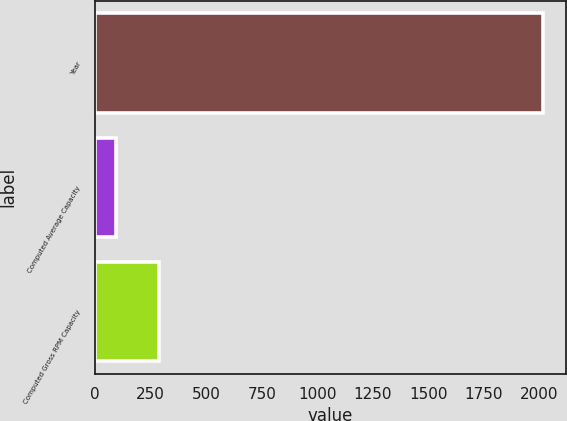Convert chart. <chart><loc_0><loc_0><loc_500><loc_500><bar_chart><fcel>Year<fcel>Computed Average Capacity<fcel>Computed Gross RPM Capacity<nl><fcel>2017<fcel>95<fcel>287.2<nl></chart> 